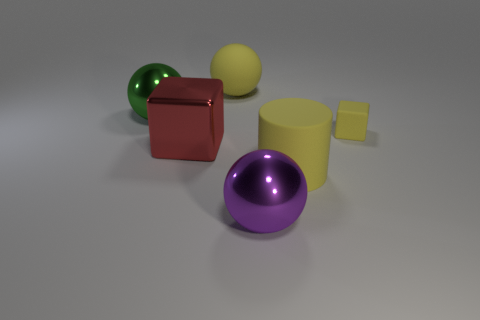How many gray metallic things are the same shape as the big green object?
Give a very brief answer. 0. There is a small object that is the same color as the rubber ball; what material is it?
Provide a succinct answer. Rubber. What is the color of the thing in front of the big yellow thing that is to the right of the metallic sphere that is in front of the red block?
Keep it short and to the point. Purple. What number of big objects are either yellow objects or cyan metal things?
Offer a terse response. 2. Are there the same number of large purple shiny balls left of the purple thing and small yellow blocks?
Your answer should be compact. No. Are there any large green metal balls behind the large green metal thing?
Offer a terse response. No. How many matte things are tiny yellow cubes or yellow spheres?
Your answer should be very brief. 2. What number of small yellow things are right of the big red block?
Offer a terse response. 1. Are there any rubber cylinders that have the same size as the yellow matte ball?
Ensure brevity in your answer.  Yes. Is there a large rubber sphere of the same color as the large cylinder?
Your answer should be very brief. Yes. 